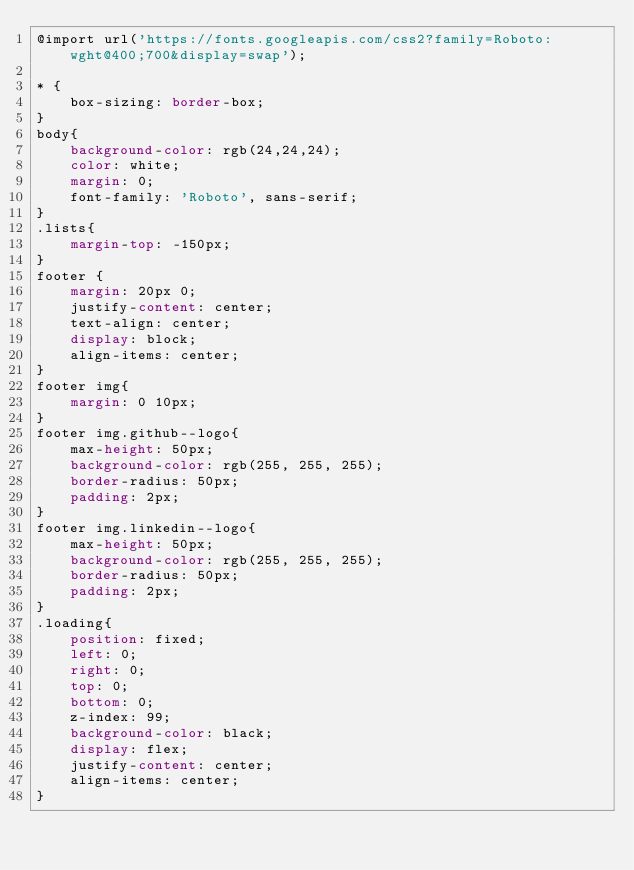Convert code to text. <code><loc_0><loc_0><loc_500><loc_500><_CSS_>@import url('https://fonts.googleapis.com/css2?family=Roboto:wght@400;700&display=swap');

* {
    box-sizing: border-box;
}
body{
    background-color: rgb(24,24,24);
    color: white;
    margin: 0;
    font-family: 'Roboto', sans-serif;
}
.lists{
    margin-top: -150px;
}
footer {
    margin: 20px 0;
    justify-content: center;
    text-align: center;
    display: block;
    align-items: center;
}
footer img{
    margin: 0 10px;
}
footer img.github--logo{
    max-height: 50px;
    background-color: rgb(255, 255, 255);
    border-radius: 50px;
    padding: 2px;
}
footer img.linkedin--logo{
    max-height: 50px;
    background-color: rgb(255, 255, 255);
    border-radius: 50px;
    padding: 2px;
}
.loading{
    position: fixed;
    left: 0;
    right: 0;
    top: 0;
    bottom: 0;
    z-index: 99;
    background-color: black;
    display: flex;
    justify-content: center;
    align-items: center;
}</code> 